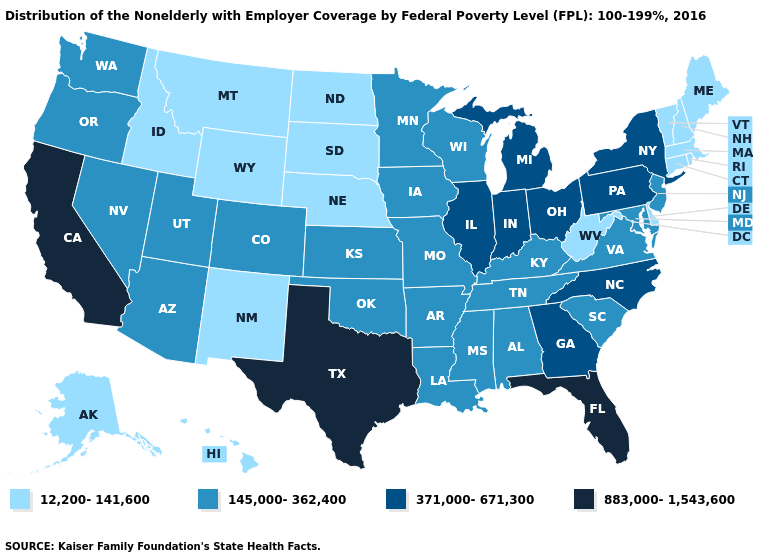Does Louisiana have the highest value in the South?
Give a very brief answer. No. Among the states that border North Carolina , which have the lowest value?
Give a very brief answer. South Carolina, Tennessee, Virginia. What is the value of Arkansas?
Keep it brief. 145,000-362,400. Does Tennessee have a lower value than Missouri?
Quick response, please. No. Which states have the lowest value in the USA?
Answer briefly. Alaska, Connecticut, Delaware, Hawaii, Idaho, Maine, Massachusetts, Montana, Nebraska, New Hampshire, New Mexico, North Dakota, Rhode Island, South Dakota, Vermont, West Virginia, Wyoming. How many symbols are there in the legend?
Write a very short answer. 4. Which states have the lowest value in the USA?
Short answer required. Alaska, Connecticut, Delaware, Hawaii, Idaho, Maine, Massachusetts, Montana, Nebraska, New Hampshire, New Mexico, North Dakota, Rhode Island, South Dakota, Vermont, West Virginia, Wyoming. What is the value of Mississippi?
Answer briefly. 145,000-362,400. What is the lowest value in the MidWest?
Write a very short answer. 12,200-141,600. Does the first symbol in the legend represent the smallest category?
Answer briefly. Yes. Name the states that have a value in the range 883,000-1,543,600?
Answer briefly. California, Florida, Texas. Which states have the lowest value in the South?
Short answer required. Delaware, West Virginia. What is the value of Indiana?
Concise answer only. 371,000-671,300. Does Arkansas have the same value as California?
Give a very brief answer. No. Name the states that have a value in the range 883,000-1,543,600?
Be succinct. California, Florida, Texas. 